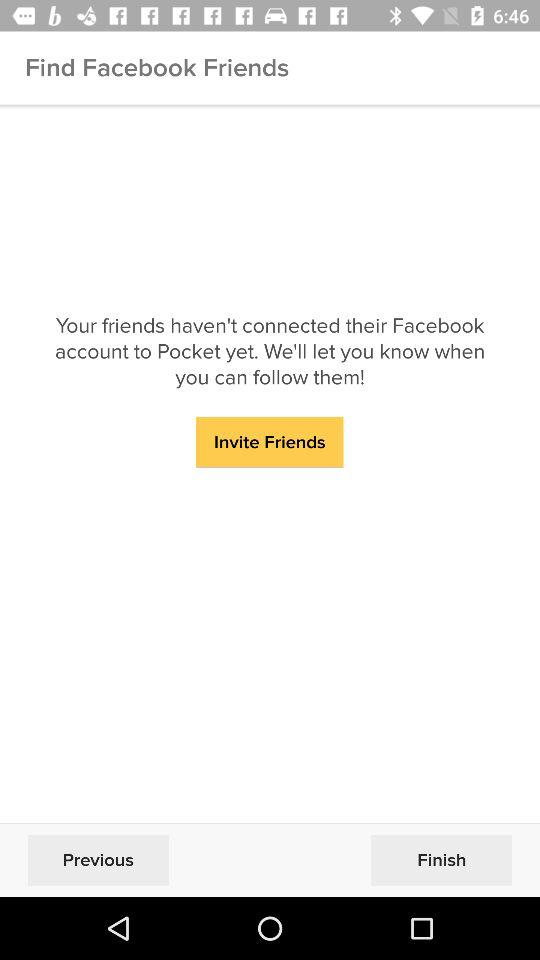What application can be used to find about the friends? The application that can be used to find about the friends is "Pocket". 